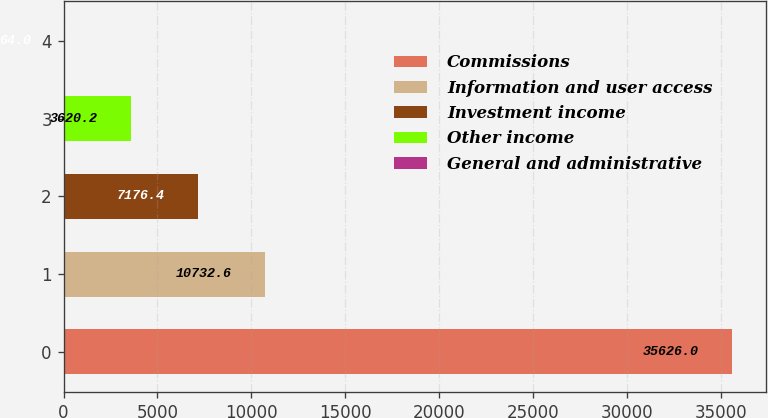Convert chart. <chart><loc_0><loc_0><loc_500><loc_500><bar_chart><fcel>Commissions<fcel>Information and user access<fcel>Investment income<fcel>Other income<fcel>General and administrative<nl><fcel>35626<fcel>10732.6<fcel>7176.4<fcel>3620.2<fcel>64<nl></chart> 